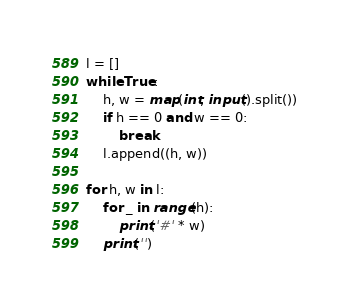<code> <loc_0><loc_0><loc_500><loc_500><_Python_>l = []
while True:
    h, w = map(int, input().split())
    if h == 0 and w == 0:
        break
    l.append((h, w))

for h, w in l:
    for _ in range(h):
        print('#' * w)
    print('')
</code> 